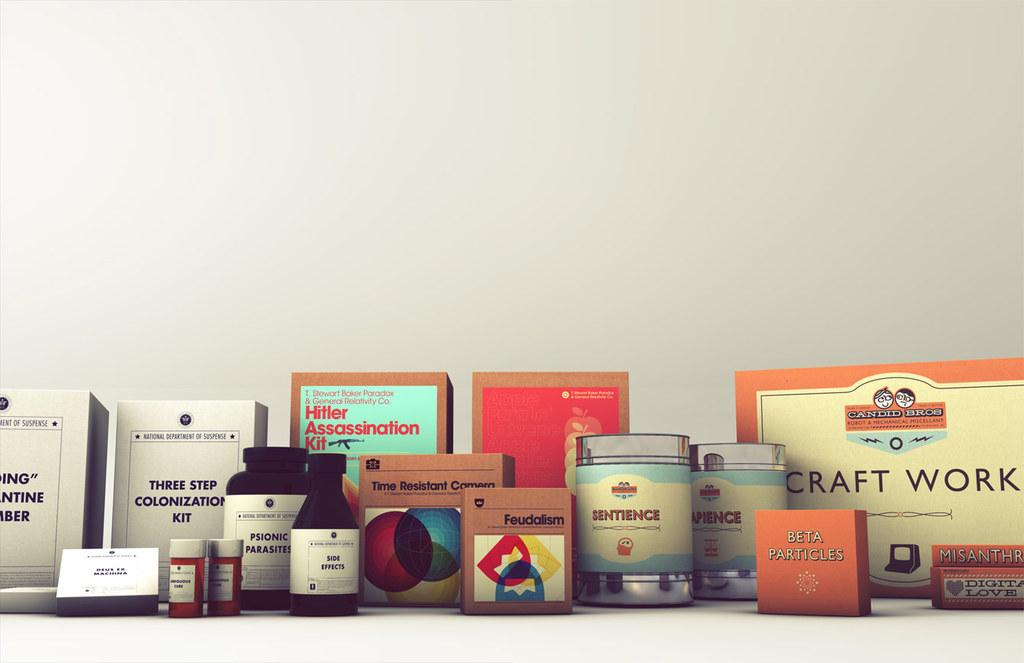Provide a one-sentence caption for the provided image. A shelf full of boxes and jars of odd items one being Hitler Assassination kit. 